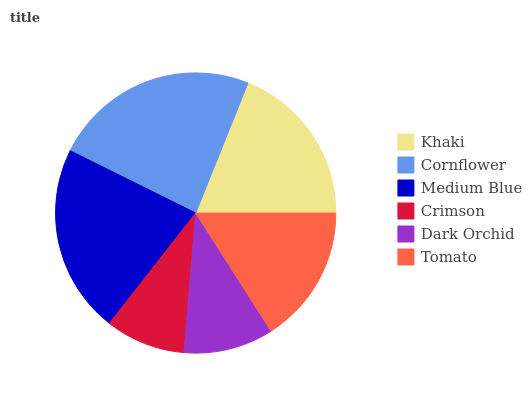Is Crimson the minimum?
Answer yes or no. Yes. Is Cornflower the maximum?
Answer yes or no. Yes. Is Medium Blue the minimum?
Answer yes or no. No. Is Medium Blue the maximum?
Answer yes or no. No. Is Cornflower greater than Medium Blue?
Answer yes or no. Yes. Is Medium Blue less than Cornflower?
Answer yes or no. Yes. Is Medium Blue greater than Cornflower?
Answer yes or no. No. Is Cornflower less than Medium Blue?
Answer yes or no. No. Is Khaki the high median?
Answer yes or no. Yes. Is Tomato the low median?
Answer yes or no. Yes. Is Tomato the high median?
Answer yes or no. No. Is Cornflower the low median?
Answer yes or no. No. 